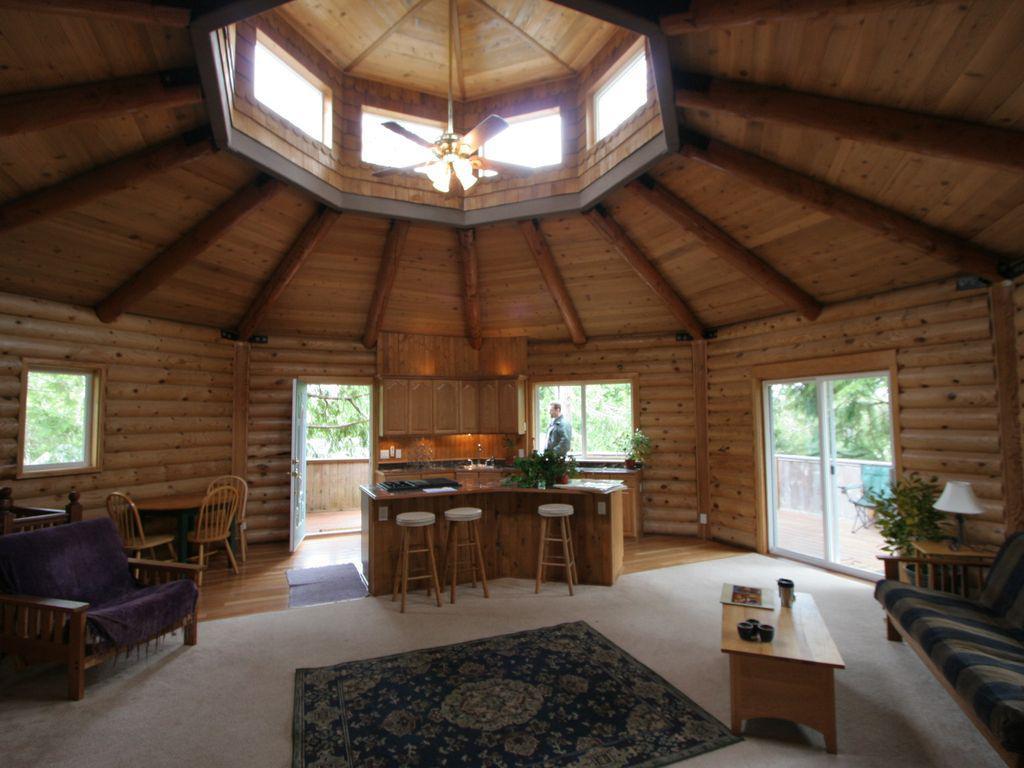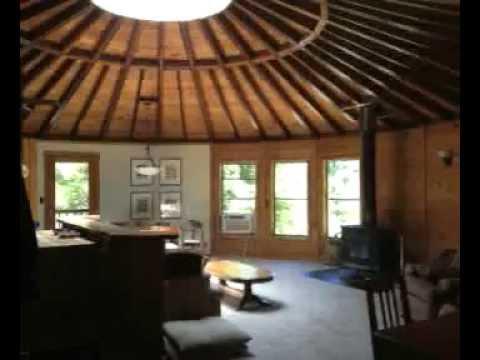The first image is the image on the left, the second image is the image on the right. Analyze the images presented: Is the assertion "An image shows a sky-light type many-sided element at the peak of a room's ceiling." valid? Answer yes or no. Yes. The first image is the image on the left, the second image is the image on the right. Analyze the images presented: Is the assertion "One image shows the kitchen of a yurt with white refrigerator and microwave, near a dining seating area with wooden kitchen chairs." valid? Answer yes or no. No. The first image is the image on the left, the second image is the image on the right. Given the left and right images, does the statement "One image shows the kitchen of a yurt with white refrigerator and microwave and a vase of flowers near a dining seating area with wooden kitchen chairs." hold true? Answer yes or no. No. 